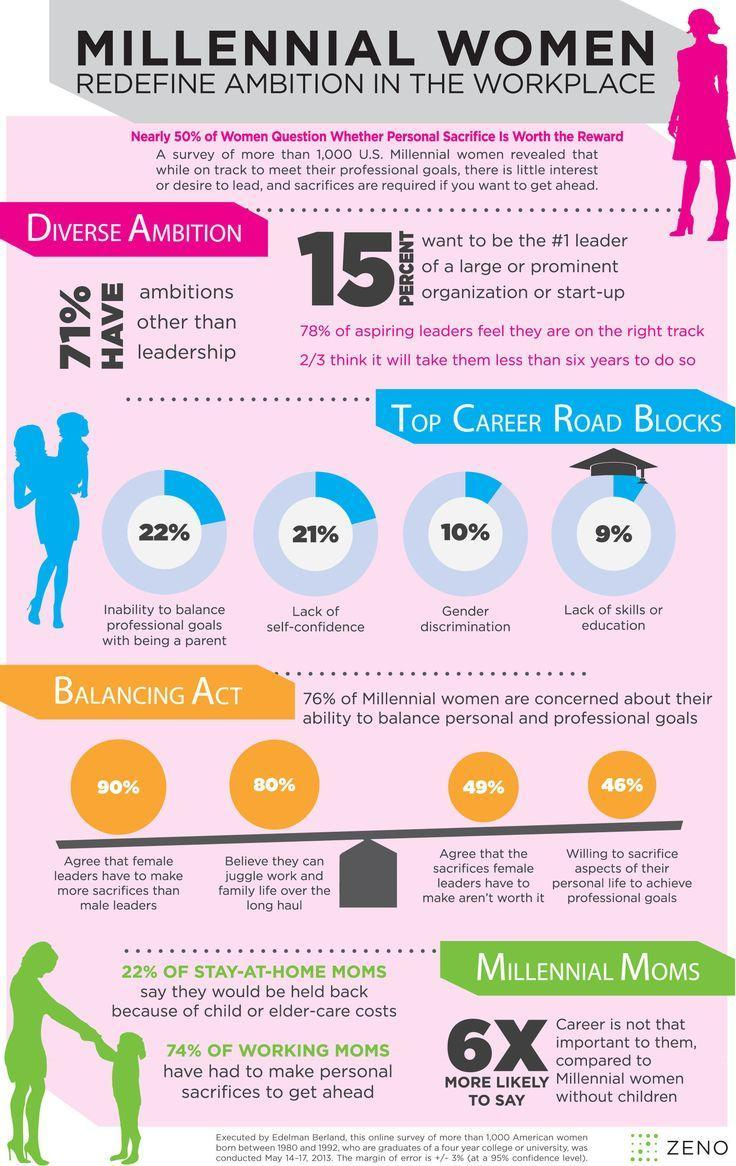For every millennial woman without children, how many millennial moms think that career is not that important
Answer the question with a short phrase. 6 How many agree that female leaders have to make more sacrifices than male leaders 90% What % of women have lack of self-confidence as a top career road block 21% What are the bottom 2 reasons for career road blocks Gender discrimination, lack of skills or education How many agree that the sacrifices female leaders have to make aren't worth it 49% 